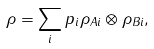<formula> <loc_0><loc_0><loc_500><loc_500>\rho = \sum _ { i } p _ { i } \rho _ { A i } \otimes \rho _ { B i } ,</formula> 